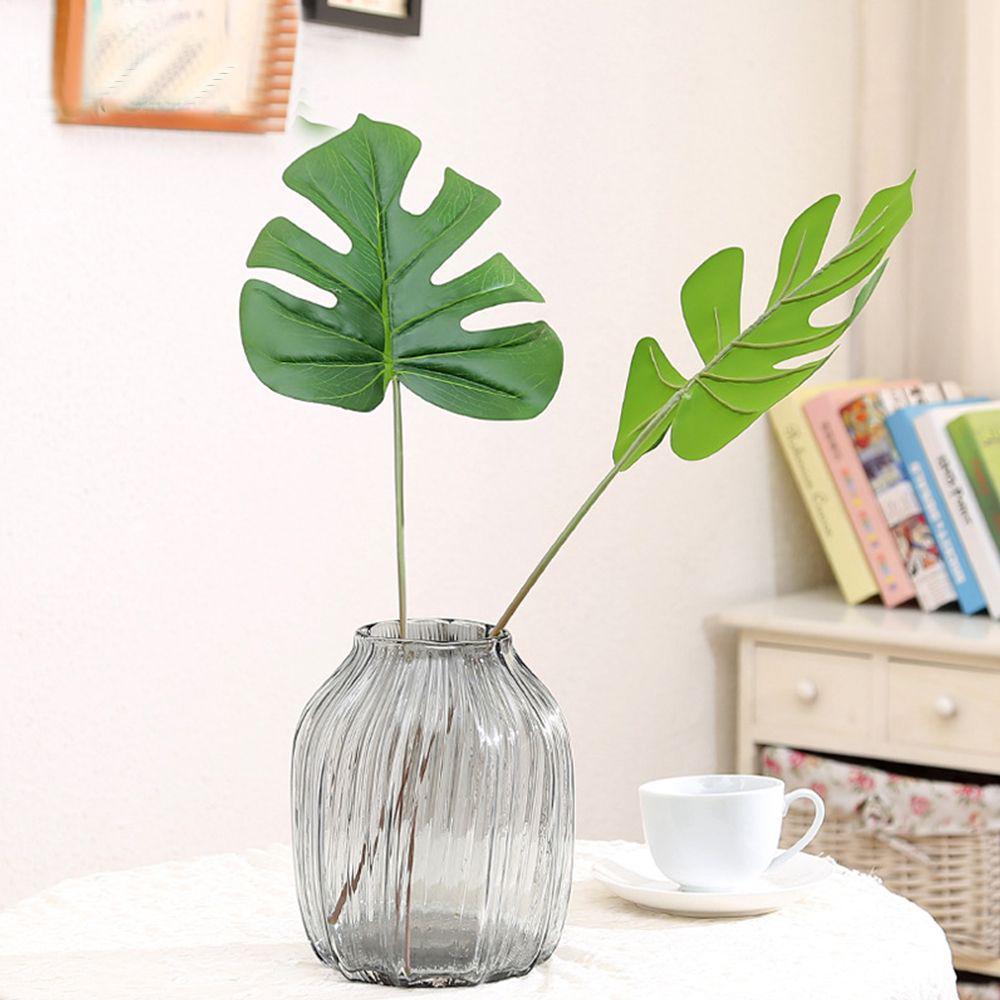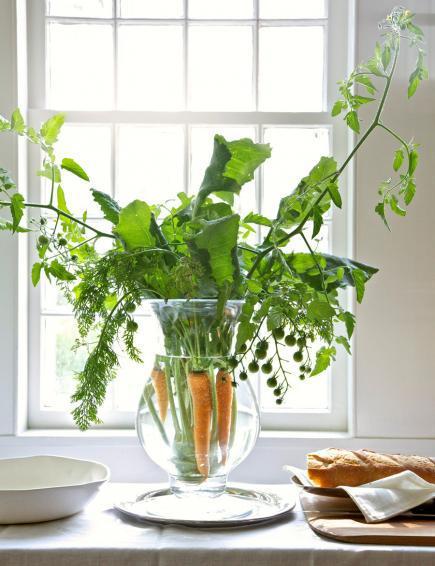The first image is the image on the left, the second image is the image on the right. For the images shown, is this caption "In one of the image there is vase with a plant in it in front of a window." true? Answer yes or no. Yes. The first image is the image on the left, the second image is the image on the right. Assess this claim about the two images: "At least one of the images shows one or more candles next to a plant.". Correct or not? Answer yes or no. No. 